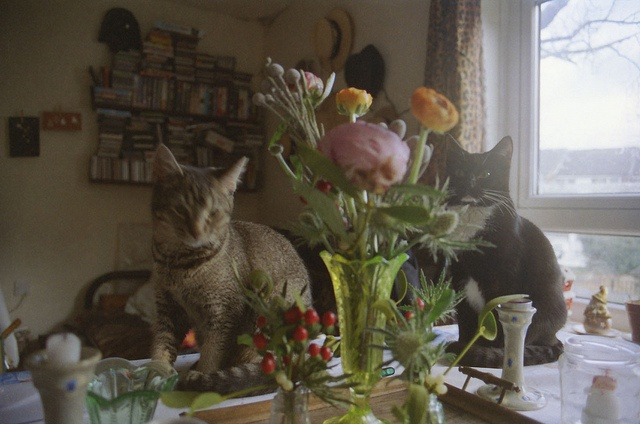Describe the objects in this image and their specific colors. I can see potted plant in black, darkgreen, and gray tones, book in black and gray tones, cat in black and gray tones, cat in black and gray tones, and cup in black, darkgray, gray, and lavender tones in this image. 